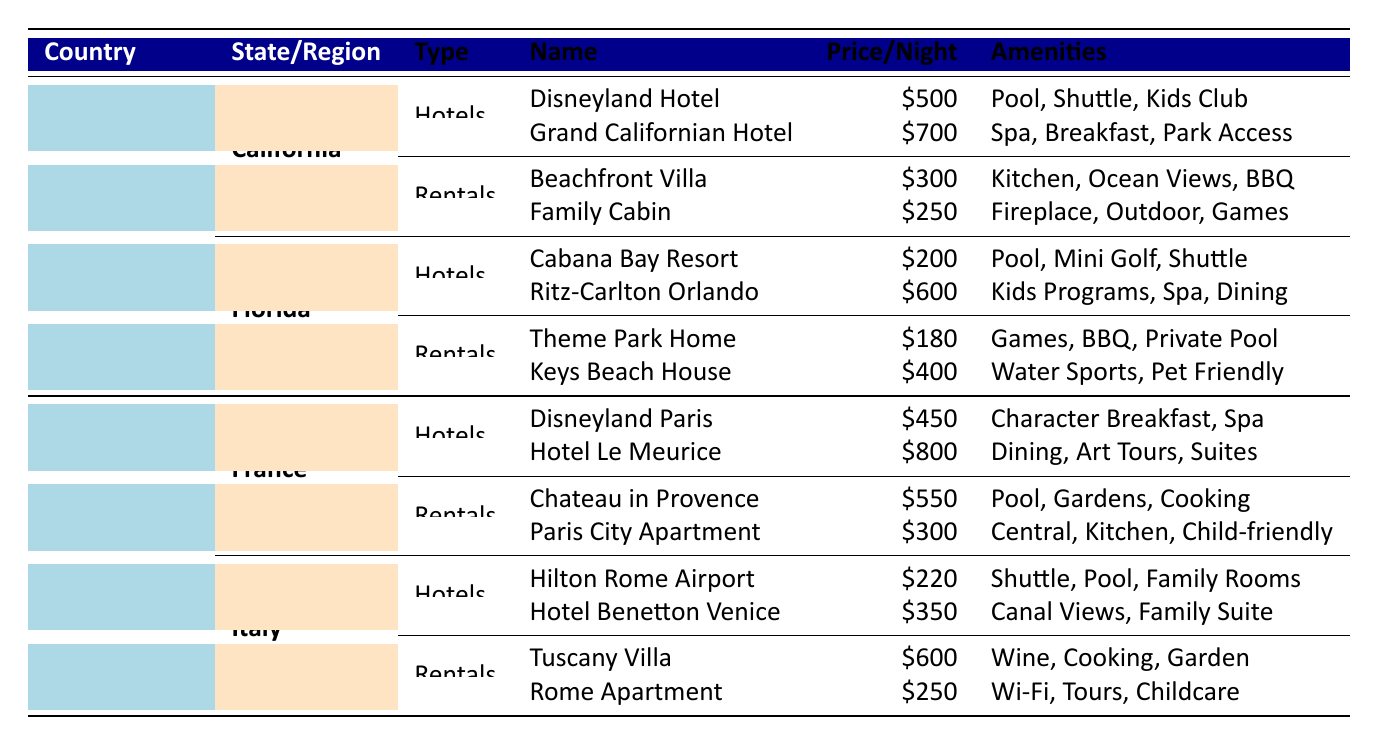What is the average price per night for hotels in California? The hotels listed in California are Disneyland Hotel at $500 and Grand Californian Hotel at $700. To find the average, add the prices: 500 + 700 = 1200. Then divide by the number of hotels: 1200 / 2 = 600.
Answer: 600 Which vacation rental in Florida is the least expensive? The vacation rentals in Florida are the Orlando Theme Park Home at $180 and the Florida Keys Beach House at $400. Comparing these prices, $180 is the lower amount.
Answer: Orlando Theme Park Home Do any accommodations in Italy offer children-friendly amenities? The hotels in Italy include Hilton Rome Airport and Hotel Benetton Venice, which do not specify child-friendly amenities. The vacation rentals are Tuscany Vineyard Villa and Rome Apartment near Colosseum, with the Rome Apartment listing "Childcare Services" as an amenity. Thus, it qualifies.
Answer: Yes Which hotel in France is the most expensive? The hotels in France are Disneyland Paris Hotel at $450 and Hotel Le Meurice at $800. Comparing these prices, Hotel Le Meurice at $800 is the most costly hotel option.
Answer: Hotel Le Meurice What is the total average price per night for all vacation rentals across the United States? In the United States, vacation rentals listed are Beachfront Villa ($300), Family Cabin in the Woods ($250), Orlando Theme Park Home ($180), and Florida Keys Beach House ($400). Adding the prices gives 300 + 250 + 180 + 400 = 1130. Since there are four rentals, the average is 1130 / 4 = 282.5.
Answer: 282.5 Is the Disneyland Hotel more expensive than any hotel in Florida? The Disneyland Hotel is priced at $500, while the Florida hotels are Cabana Bay Beach Resort at $200 and Ritz-Carlton Orlando at $600. Since $500 is less than $600 but greater than $200, it is not more expensive than all Florida hotels.
Answer: No What amenities do hotels in California offer that are not listed for hotels in Florida? The amenities for California hotels include Pool, Shuttle Service, Kids Club, Spa, Free Breakfast, and Theme Park Access. Florida hotels list Pool, Mini Golf, Free Shuttle, Kids Programs, Spa, and Fine Dining. Notably, Kids Club and Theme Park Access from California hotels do not appear in Florida hotels.
Answer: Kids Club, Theme Park Access 